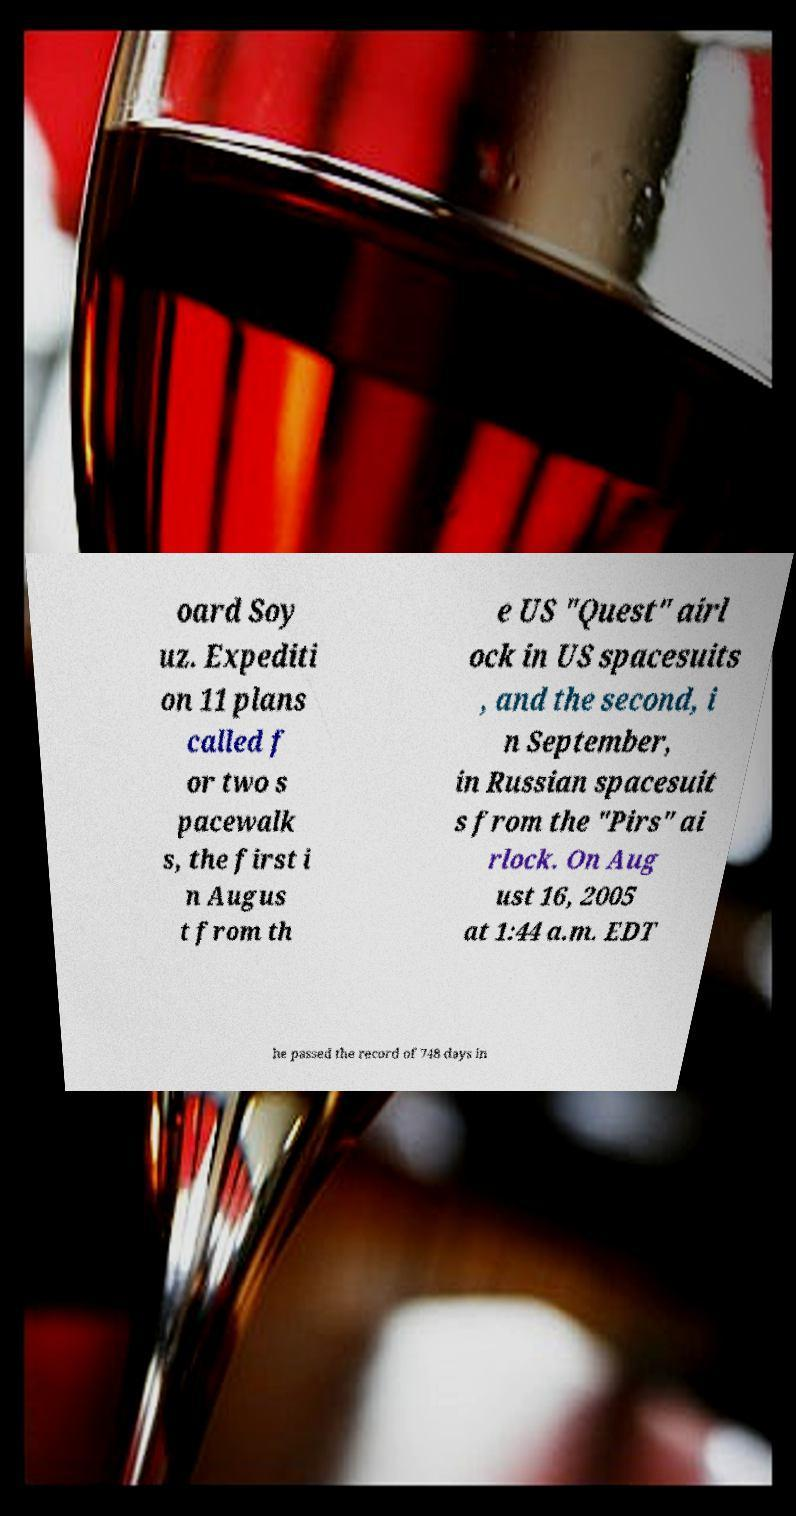Could you assist in decoding the text presented in this image and type it out clearly? oard Soy uz. Expediti on 11 plans called f or two s pacewalk s, the first i n Augus t from th e US "Quest" airl ock in US spacesuits , and the second, i n September, in Russian spacesuit s from the "Pirs" ai rlock. On Aug ust 16, 2005 at 1:44 a.m. EDT he passed the record of 748 days in 